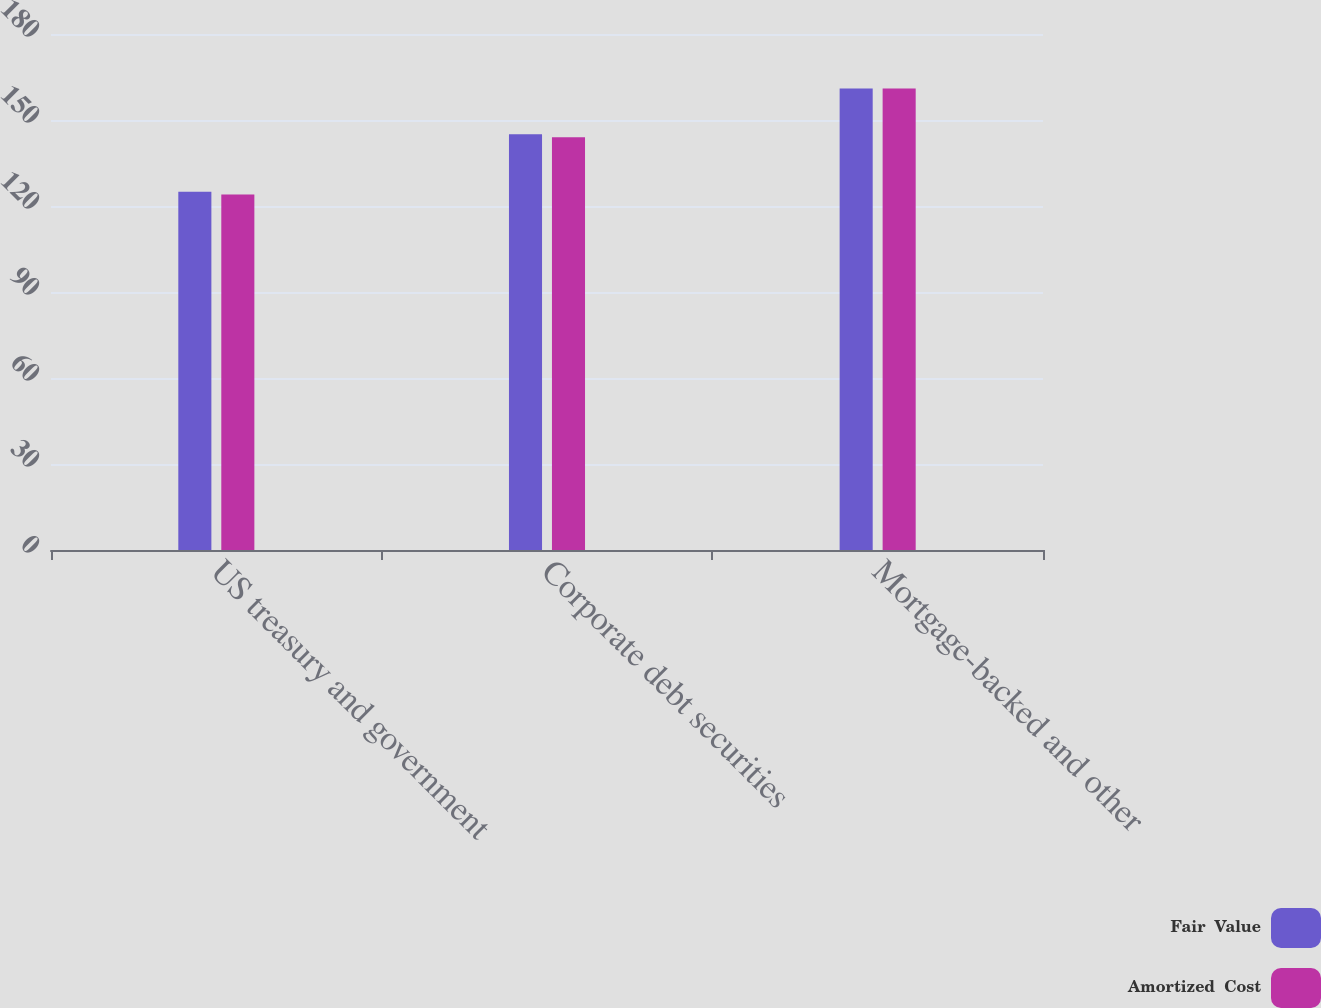Convert chart. <chart><loc_0><loc_0><loc_500><loc_500><stacked_bar_chart><ecel><fcel>US treasury and government<fcel>Corporate debt securities<fcel>Mortgage-backed and other<nl><fcel>Fair  Value<fcel>125<fcel>145<fcel>161<nl><fcel>Amortized  Cost<fcel>124<fcel>144<fcel>161<nl></chart> 